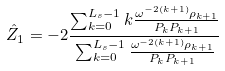Convert formula to latex. <formula><loc_0><loc_0><loc_500><loc_500>\hat { Z } _ { 1 } = - 2 \frac { \sum _ { k = 0 } ^ { L _ { s } - 1 } k \frac { \omega ^ { - 2 ( k + 1 ) } \rho _ { k + 1 } } { P _ { k } P _ { k + 1 } } } { \sum _ { k = 0 } ^ { L _ { s } - 1 } \frac { \omega ^ { - 2 ( k + 1 ) } \rho _ { k + 1 } } { P _ { k } P _ { k + 1 } } }</formula> 